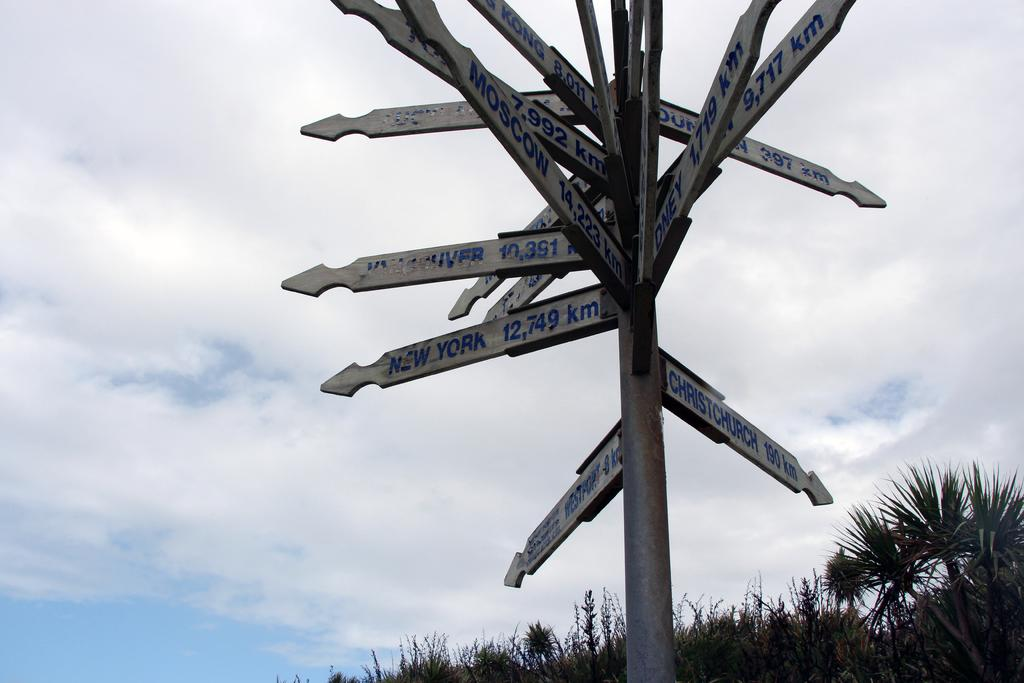<image>
Relay a brief, clear account of the picture shown. A sign shows the distance in kilometers to many different places. 